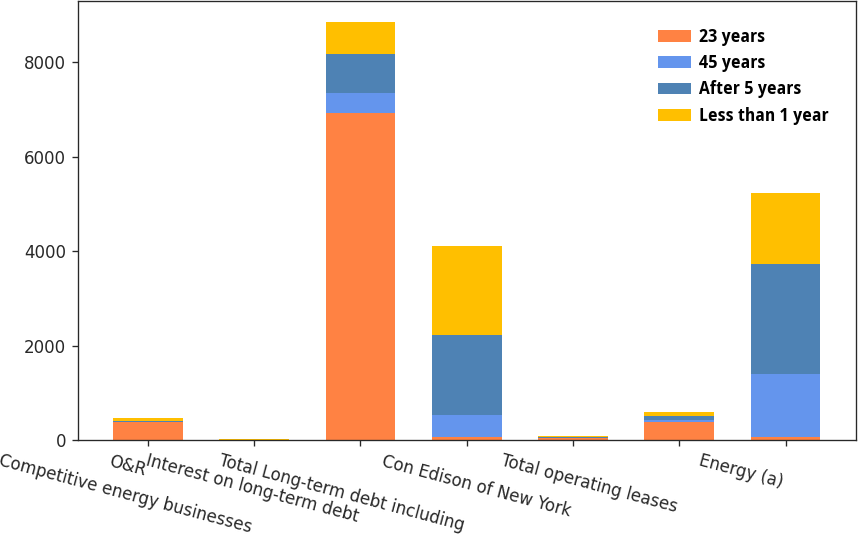Convert chart to OTSL. <chart><loc_0><loc_0><loc_500><loc_500><stacked_bar_chart><ecel><fcel>O&R<fcel>Competitive energy businesses<fcel>Interest on long-term debt<fcel>Total Long-term debt including<fcel>Con Edison of New York<fcel>Total operating leases<fcel>Energy (a)<nl><fcel>23 years<fcel>388<fcel>12<fcel>6926<fcel>82.5<fcel>49<fcel>392<fcel>82.5<nl><fcel>45 years<fcel>2<fcel>2<fcel>430<fcel>452<fcel>7<fcel>40<fcel>1327<nl><fcel>After 5 years<fcel>25<fcel>4<fcel>809<fcel>1690<fcel>15<fcel>82<fcel>2325<nl><fcel>Less than 1 year<fcel>61<fcel>3<fcel>685<fcel>1877<fcel>15<fcel>83<fcel>1488<nl></chart> 